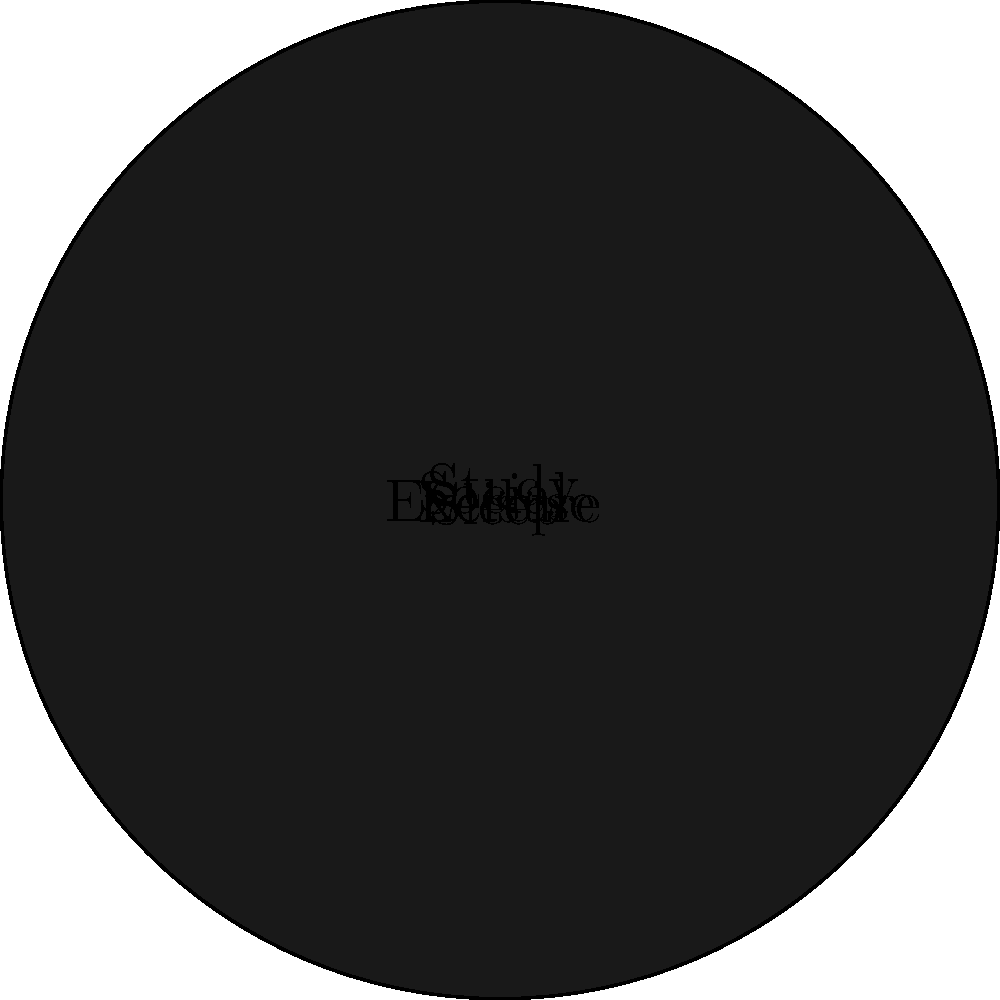In the pie chart representing your daily activities, what is the central angle (in degrees) of the sector corresponding to "Sleep"? To find the central angle for "Sleep", we need to follow these steps:

1. Calculate the total hours: $3 + 5 + 2 + 6 + 8 = 24$ hours

2. Identify the hours spent on sleep: 6 hours

3. Use the formula for central angle:
   $\text{Central Angle} = \frac{\text{Category Value}}{\text{Total}} \times 360°$

4. Plug in the values:
   $\text{Central Angle} = \frac{6}{24} \times 360°$

5. Simplify:
   $\text{Central Angle} = 0.25 \times 360° = 90°$

Therefore, the central angle for the "Sleep" sector is 90°.
Answer: $90°$ 